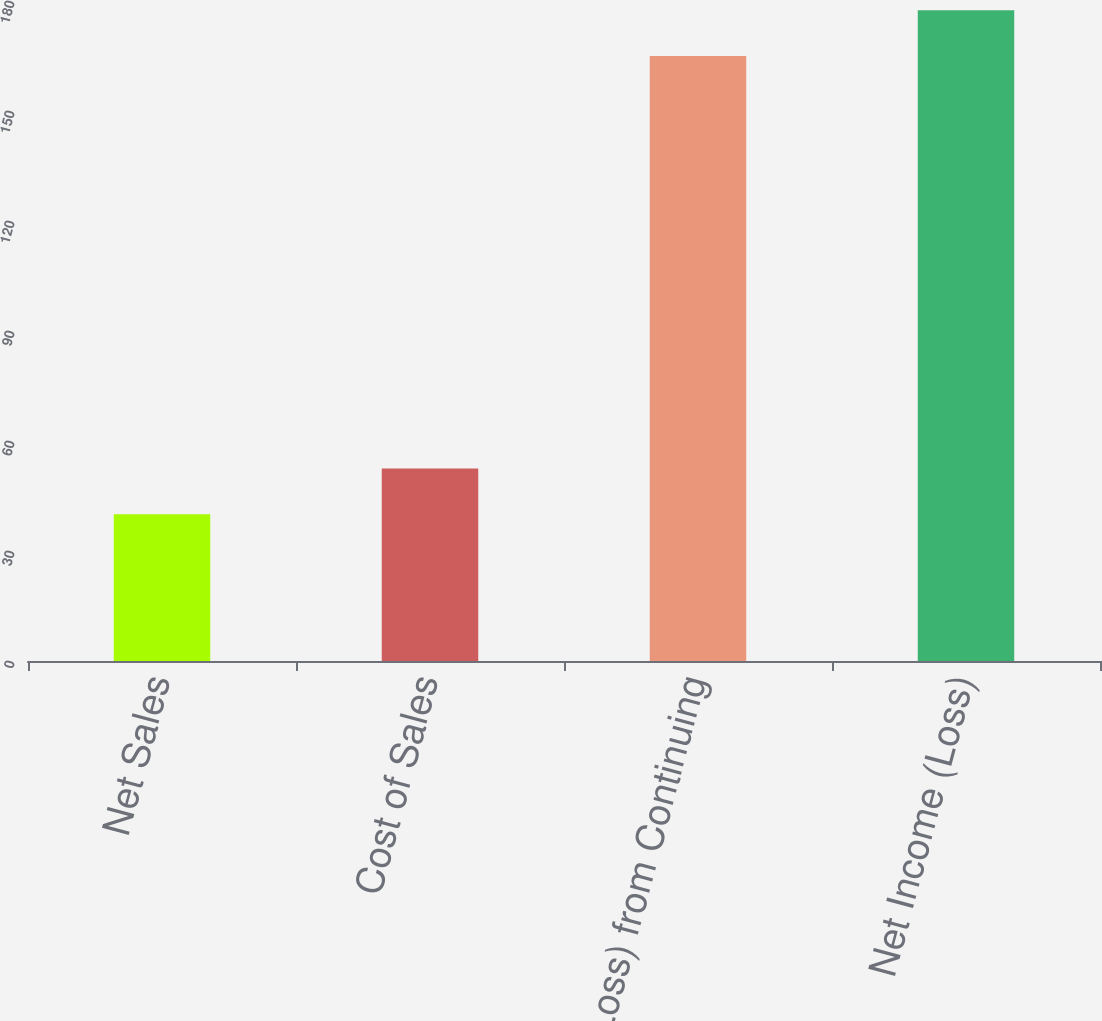Convert chart to OTSL. <chart><loc_0><loc_0><loc_500><loc_500><bar_chart><fcel>Net Sales<fcel>Cost of Sales<fcel>Income (Loss) from Continuing<fcel>Net Income (Loss)<nl><fcel>40<fcel>52.5<fcel>165<fcel>177.5<nl></chart> 